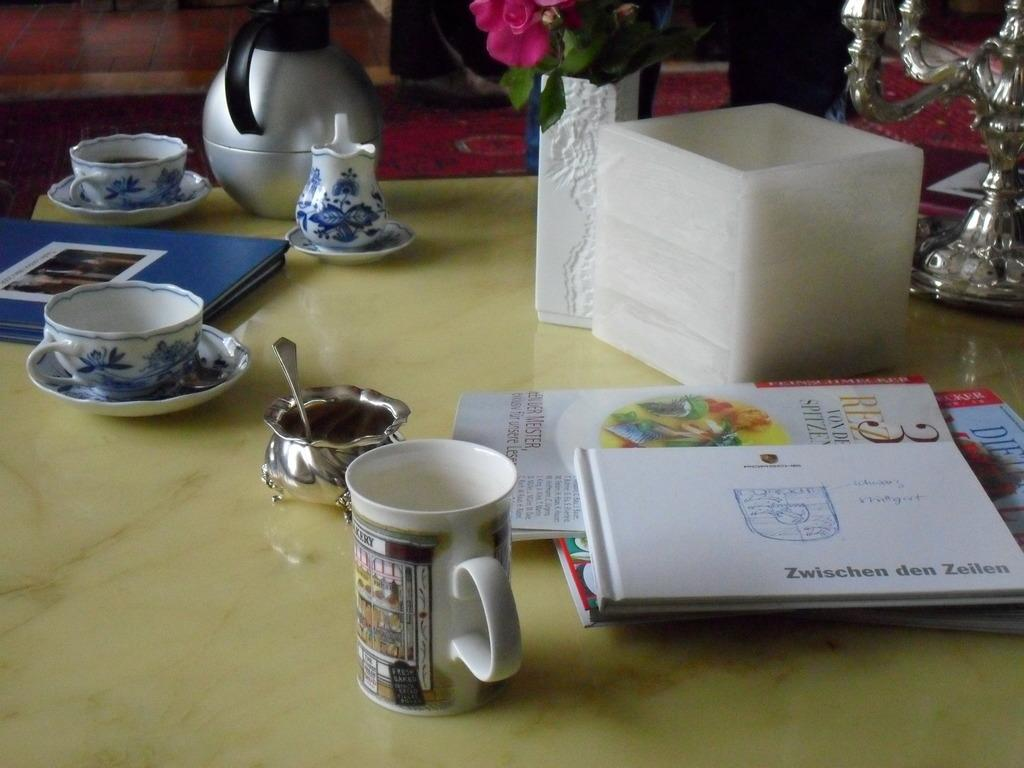What piece of furniture is present in the image? There is a table in the image. What items can be seen on the table? There is a cup, a saucer, a book, a kettle, a vase with a flower, papers, a box, and a spoon on the table. Can you describe the contents of the vase? The vase contains a flower. What might be used for stirring or scooping in the image? A spoon is present on the table for stirring or scooping. What channel is the TV showing in the image? There is no TV present in the image, so it is not possible to determine what channel might be showing. 